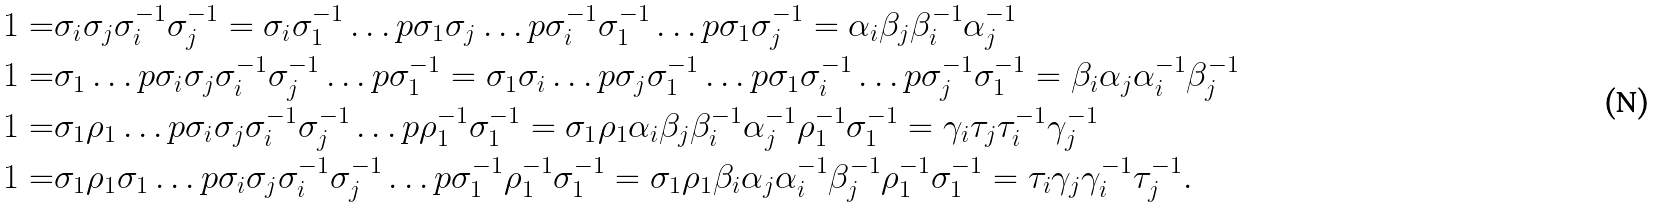<formula> <loc_0><loc_0><loc_500><loc_500>1 = & \sigma _ { i } \sigma _ { j } \sigma _ { i } ^ { - 1 } \sigma _ { j } ^ { - 1 } = \sigma _ { i } \sigma _ { 1 } ^ { - 1 } \dots p \sigma _ { 1 } \sigma _ { j } \dots p \sigma _ { i } ^ { - 1 } \sigma _ { 1 } ^ { - 1 } \dots p \sigma _ { 1 } \sigma _ { j } ^ { - 1 } = \alpha _ { i } \beta _ { j } \beta _ { i } ^ { - 1 } \alpha _ { j } ^ { - 1 } \\ 1 = & \sigma _ { 1 } \dots p \sigma _ { i } \sigma _ { j } \sigma _ { i } ^ { - 1 } \sigma _ { j } ^ { - 1 } \dots p \sigma _ { 1 } ^ { - 1 } = \sigma _ { 1 } \sigma _ { i } \dots p \sigma _ { j } \sigma _ { 1 } ^ { - 1 } \dots p \sigma _ { 1 } \sigma _ { i } ^ { - 1 } \dots p \sigma _ { j } ^ { - 1 } \sigma _ { 1 } ^ { - 1 } = \beta _ { i } \alpha _ { j } \alpha _ { i } ^ { - 1 } \beta _ { j } ^ { - 1 } \\ 1 = & \sigma _ { 1 } \rho _ { 1 } \dots p \sigma _ { i } \sigma _ { j } \sigma _ { i } ^ { - 1 } \sigma _ { j } ^ { - 1 } \dots p \rho _ { 1 } ^ { - 1 } \sigma _ { 1 } ^ { - 1 } = \sigma _ { 1 } \rho _ { 1 } \alpha _ { i } \beta _ { j } \beta _ { i } ^ { - 1 } \alpha _ { j } ^ { - 1 } \rho _ { 1 } ^ { - 1 } \sigma _ { 1 } ^ { - 1 } = \gamma _ { i } \tau _ { j } \tau _ { i } ^ { - 1 } \gamma _ { j } ^ { - 1 } \\ 1 = & \sigma _ { 1 } \rho _ { 1 } \sigma _ { 1 } \dots p \sigma _ { i } \sigma _ { j } \sigma _ { i } ^ { - 1 } \sigma _ { j } ^ { - 1 } \dots p \sigma _ { 1 } ^ { - 1 } \rho _ { 1 } ^ { - 1 } \sigma _ { 1 } ^ { - 1 } = \sigma _ { 1 } \rho _ { 1 } \beta _ { i } \alpha _ { j } \alpha _ { i } ^ { - 1 } \beta _ { j } ^ { - 1 } \rho _ { 1 } ^ { - 1 } \sigma _ { 1 } ^ { - 1 } = \tau _ { i } \gamma _ { j } \gamma _ { i } ^ { - 1 } \tau _ { j } ^ { - 1 } .</formula> 